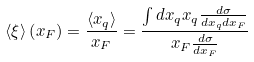<formula> <loc_0><loc_0><loc_500><loc_500>\langle \xi \rangle \left ( x _ { F } \right ) = \frac { \left \langle x _ { q } \right \rangle } { x _ { F } } = \frac { \int d x _ { q } x _ { q } \frac { d \sigma } { d x _ { q } d x _ { F } } } { x _ { F } \frac { d \sigma } { d x _ { F } } }</formula> 